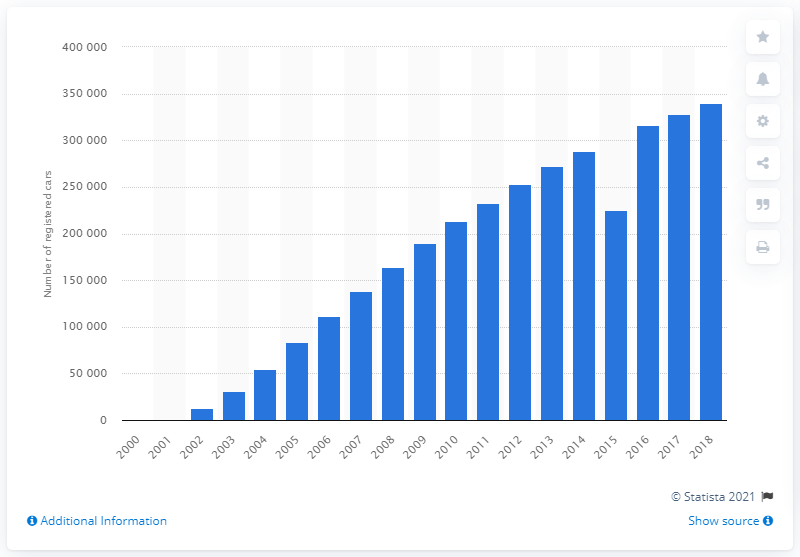Indicate a few pertinent items in this graphic. The last quarter of 2018 occurred in 2000. 